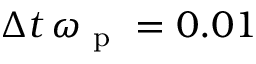Convert formula to latex. <formula><loc_0><loc_0><loc_500><loc_500>\Delta t \, \omega _ { p } = 0 . 0 1</formula> 